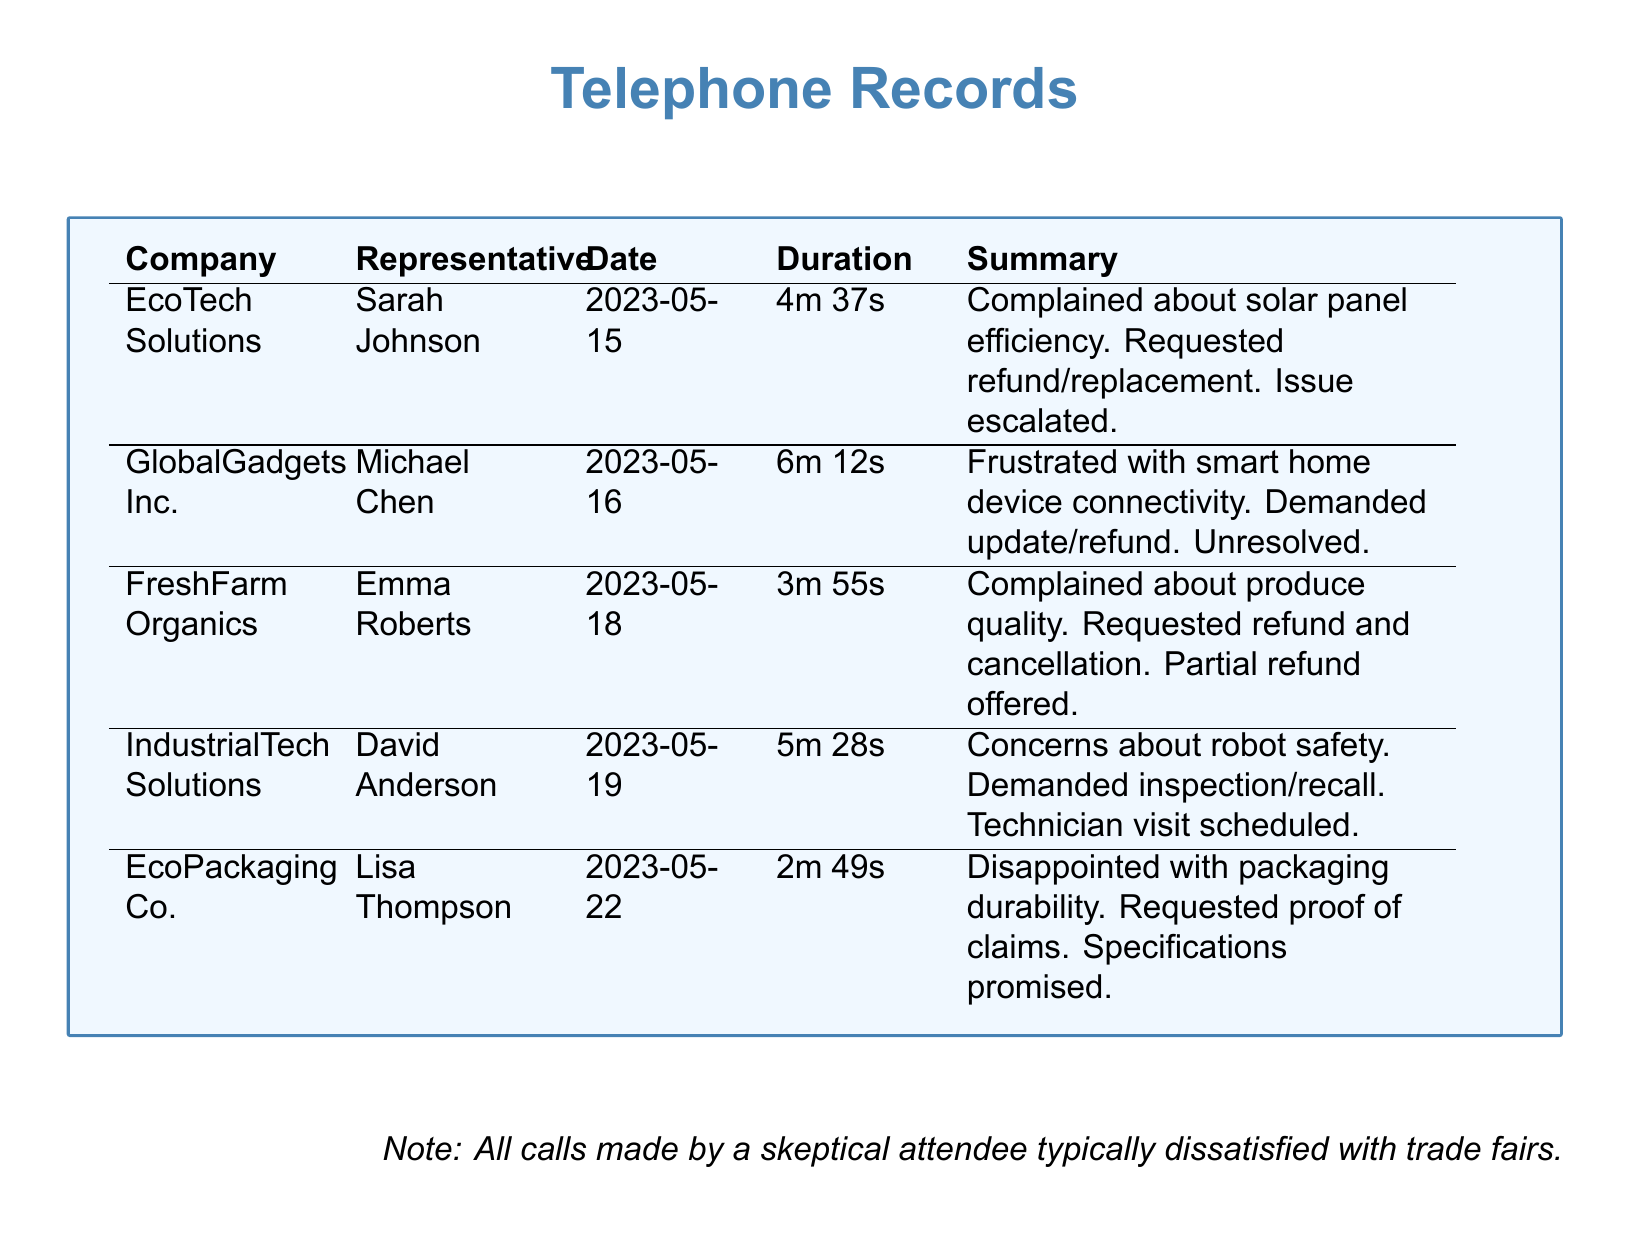what is the name of the representative from EcoTech Solutions? The document states that the representative from EcoTech Solutions is Sarah Johnson.
Answer: Sarah Johnson what was the date of the call to GlobalGadgets Inc.? The document shows that the call to GlobalGadgets Inc. was made on May 16, 2023.
Answer: 2023-05-16 how long was the call with FreshFarm Organics? According to the document, the duration of the call with FreshFarm Organics was 3 minutes and 55 seconds.
Answer: 3m 55s which company had a concern about robot safety? The document mentions that IndustrialTech Solutions had a concern about robot safety.
Answer: IndustrialTech Solutions what issue was raised during the call with EcoPackaging Co.? The document indicates that the complaint was about packaging durability.
Answer: Packaging durability how many calls were made regarding product refunds or replacements? The records show that there were three calls regarding product refunds or replacements (EcoTech Solutions, FreshFarm Organics, GlobalGadgets Inc.).
Answer: 3 what was promised to EcoPackaging Co. regarding their durability claims? The document states that specifications were promised to EcoPackaging Co. regarding their durability claims.
Answer: Specifications was any technician visit scheduled for the call with IndustrialTech Solutions? The document confirms that a technician visit was scheduled for the call with IndustrialTech Solutions.
Answer: Yes which company had a complaint about produce quality? FreshFarm Organics is the company with a complaint about produce quality, as stated in the document.
Answer: FreshFarm Organics 